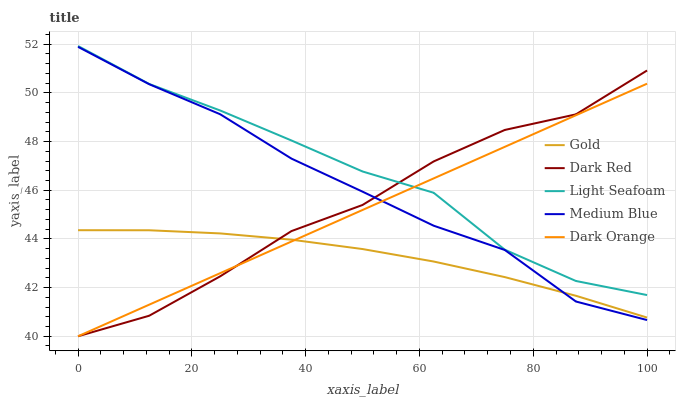Does Gold have the minimum area under the curve?
Answer yes or no. Yes. Does Light Seafoam have the maximum area under the curve?
Answer yes or no. Yes. Does Medium Blue have the minimum area under the curve?
Answer yes or no. No. Does Medium Blue have the maximum area under the curve?
Answer yes or no. No. Is Dark Orange the smoothest?
Answer yes or no. Yes. Is Dark Red the roughest?
Answer yes or no. Yes. Is Light Seafoam the smoothest?
Answer yes or no. No. Is Light Seafoam the roughest?
Answer yes or no. No. Does Dark Red have the lowest value?
Answer yes or no. Yes. Does Medium Blue have the lowest value?
Answer yes or no. No. Does Light Seafoam have the highest value?
Answer yes or no. Yes. Does Medium Blue have the highest value?
Answer yes or no. No. Is Gold less than Light Seafoam?
Answer yes or no. Yes. Is Light Seafoam greater than Medium Blue?
Answer yes or no. Yes. Does Dark Red intersect Medium Blue?
Answer yes or no. Yes. Is Dark Red less than Medium Blue?
Answer yes or no. No. Is Dark Red greater than Medium Blue?
Answer yes or no. No. Does Gold intersect Light Seafoam?
Answer yes or no. No. 